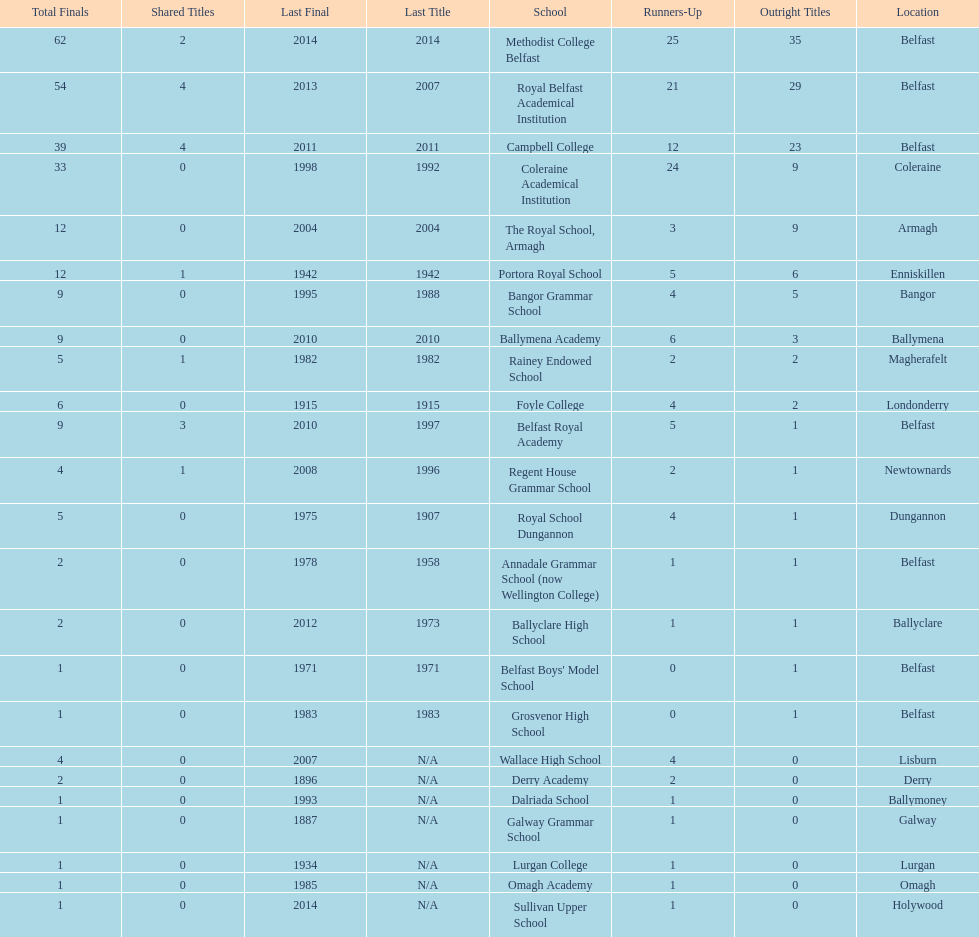How many schools held over 5 outright titles? 6. 